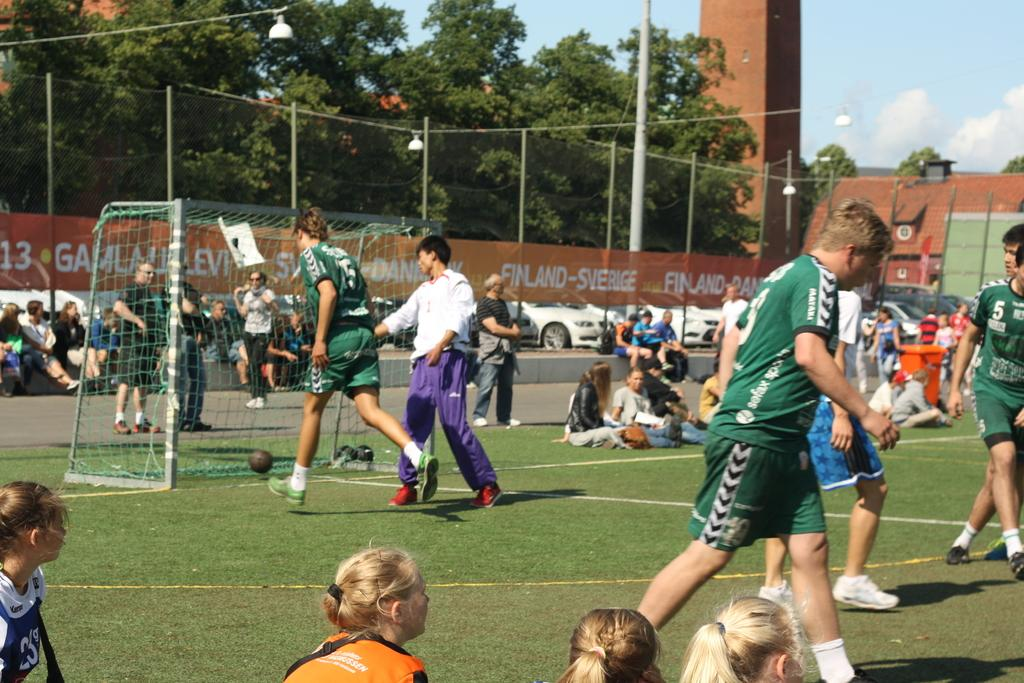Provide a one-sentence caption for the provided image. One of the sponsors of the field was Finland-Sverige. 